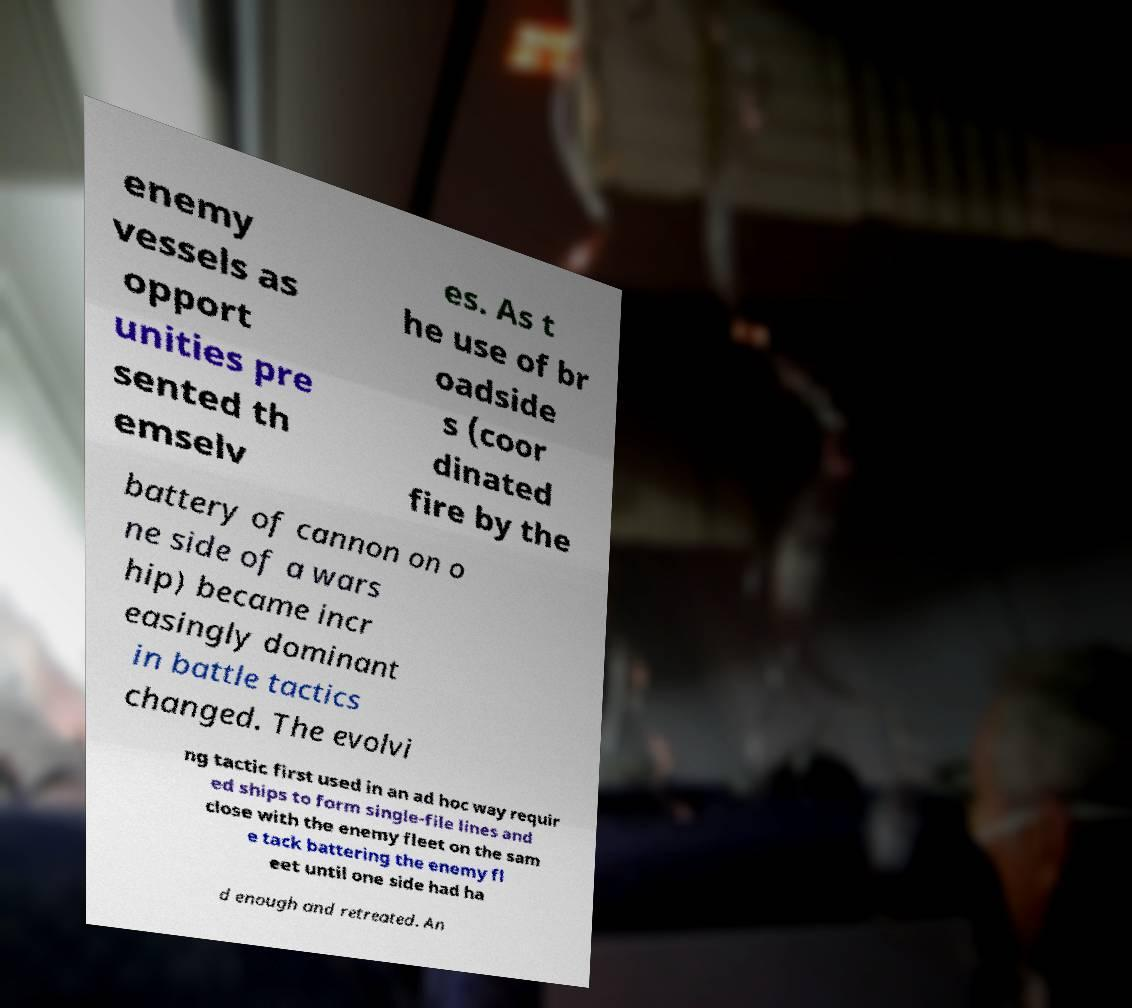Could you extract and type out the text from this image? enemy vessels as opport unities pre sented th emselv es. As t he use of br oadside s (coor dinated fire by the battery of cannon on o ne side of a wars hip) became incr easingly dominant in battle tactics changed. The evolvi ng tactic first used in an ad hoc way requir ed ships to form single-file lines and close with the enemy fleet on the sam e tack battering the enemy fl eet until one side had ha d enough and retreated. An 